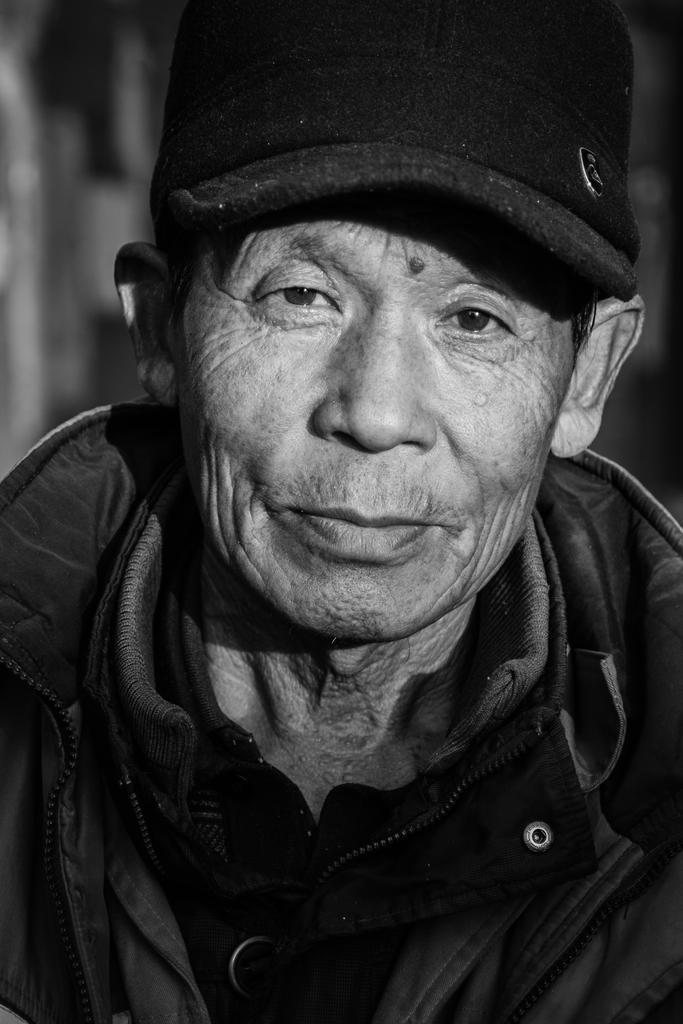How would you summarize this image in a sentence or two? This is a black and white picture, in the image we can see a person wearing a cap. 